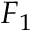Convert formula to latex. <formula><loc_0><loc_0><loc_500><loc_500>F _ { 1 }</formula> 